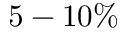<formula> <loc_0><loc_0><loc_500><loc_500>5 - 1 0 \%</formula> 